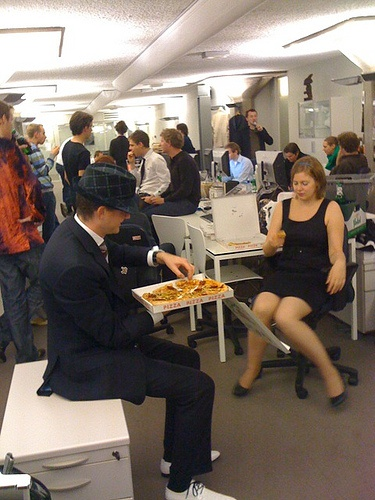Describe the objects in this image and their specific colors. I can see people in darkgray, black, gray, and maroon tones, people in darkgray, black, tan, gray, and maroon tones, people in darkgray, black, maroon, and brown tones, people in darkgray, black, maroon, and brown tones, and people in darkgray, tan, and gray tones in this image. 